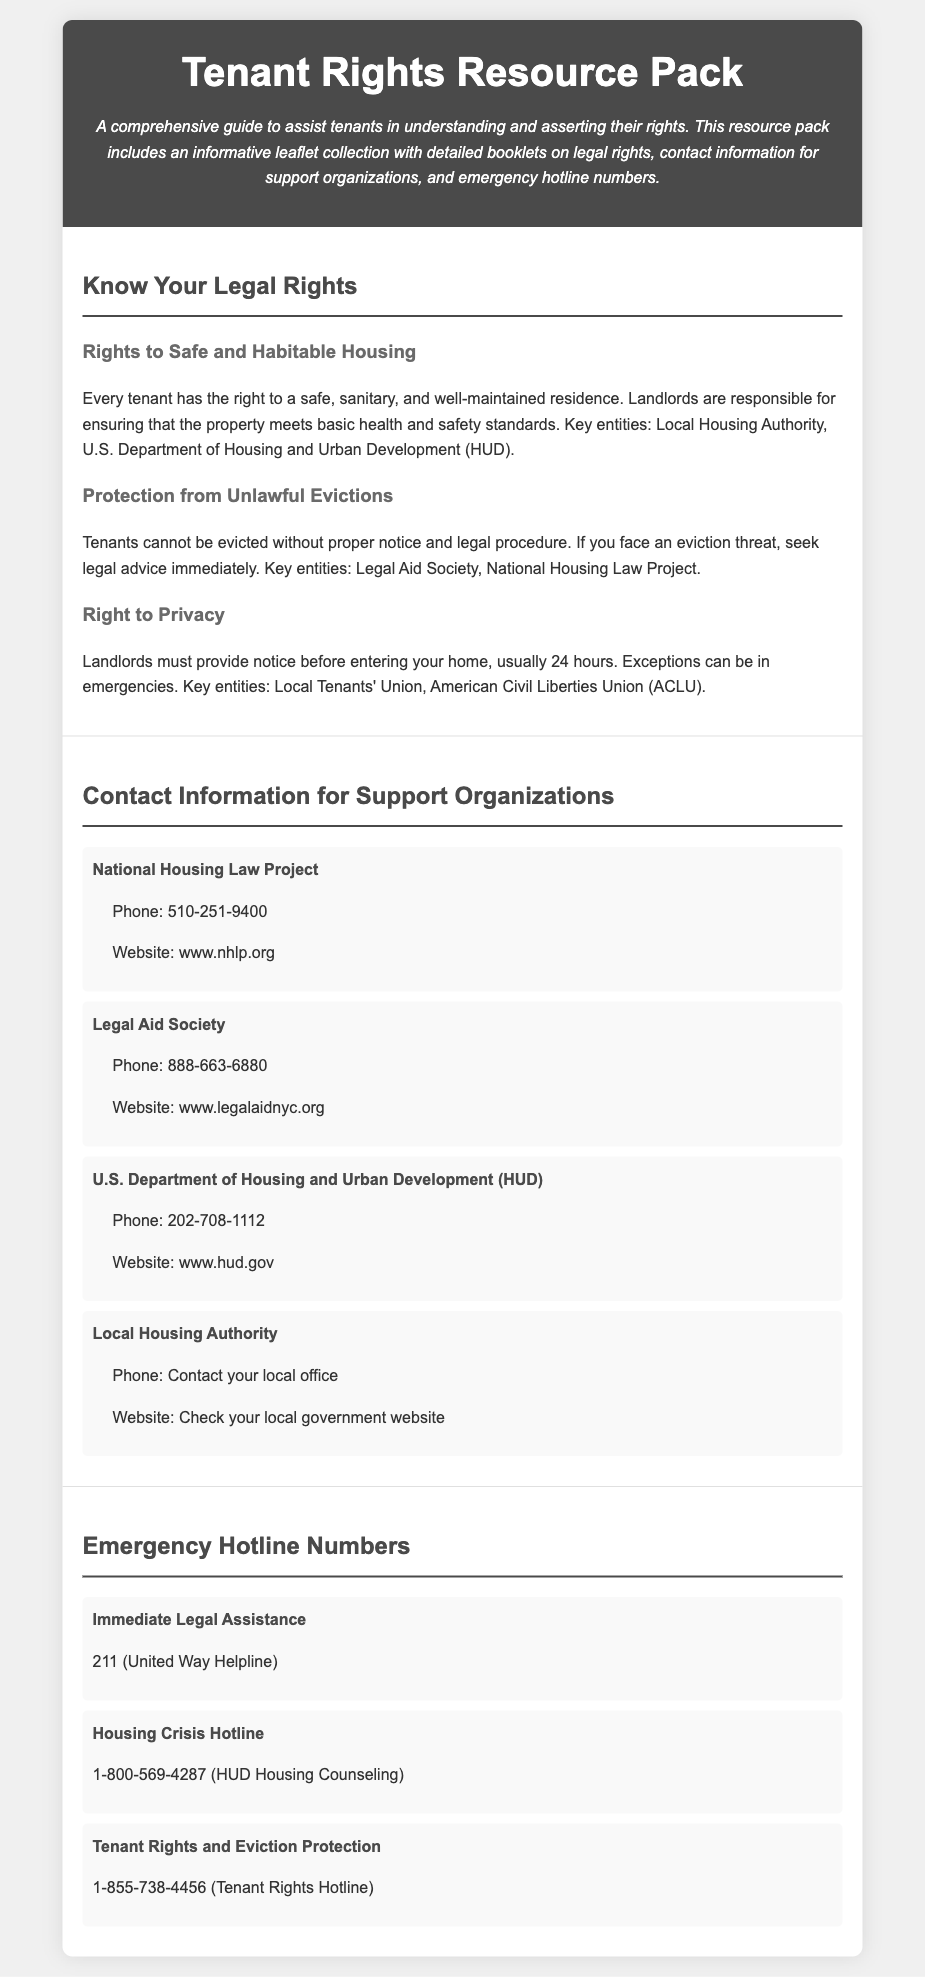What is the title of the resource pack? The title of the resource pack is prominently displayed in the header section of the document.
Answer: Tenant Rights Resource Pack What is the right associated with safe housing? This right is mentioned under the section that details tenants' legal rights, emphasizing the importance of living conditions.
Answer: Rights to Safe and Habitable Housing Who provides assistance in unlawful eviction cases? This is found under the section discussing protections for tenants facing eviction, detailing organizations that can provide help.
Answer: Legal Aid Society What number should you call for immediate legal assistance? The emergency hotline section lists several hotlines for tenants in need of immediate help and their purposes.
Answer: 211 What department is responsible for housing and urban development? The contact information section includes key governmental organizations involved in tenant rights and housing issues.
Answer: U.S. Department of Housing and Urban Development (HUD) What hotline could you call for tenant rights and eviction protection? This specific hotline number is mentioned in the emergency hotline section dedicated to tenant rights.
Answer: 1-855-738-4456 How many entities are listed under contact information for support organizations? This includes each organization listed in the contact information section, showing the resources available for tenants.
Answer: Four What is one exception to the landlord's requirement to notify before entering? The document specifies instances where landlord notification is not necessary.
Answer: Emergencies What type of assistance does the National Housing Law Project provide? This organization is mentioned in the context of providing support for a specific tenant-related legal issue.
Answer: Evictions 